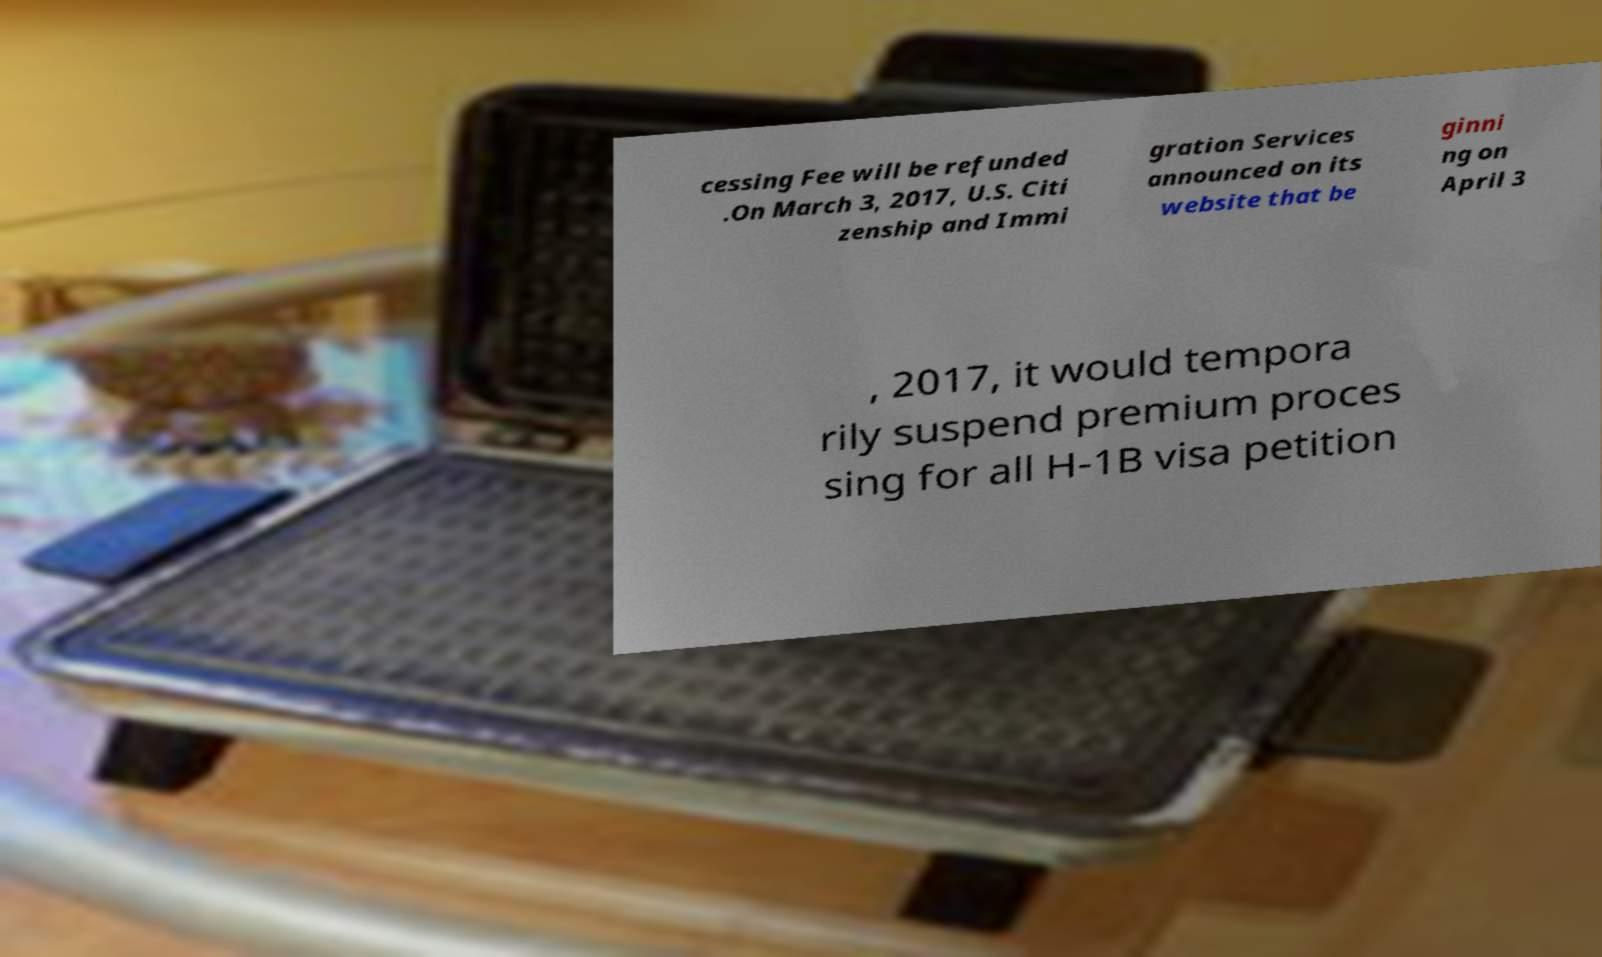I need the written content from this picture converted into text. Can you do that? cessing Fee will be refunded .On March 3, 2017, U.S. Citi zenship and Immi gration Services announced on its website that be ginni ng on April 3 , 2017, it would tempora rily suspend premium proces sing for all H-1B visa petition 